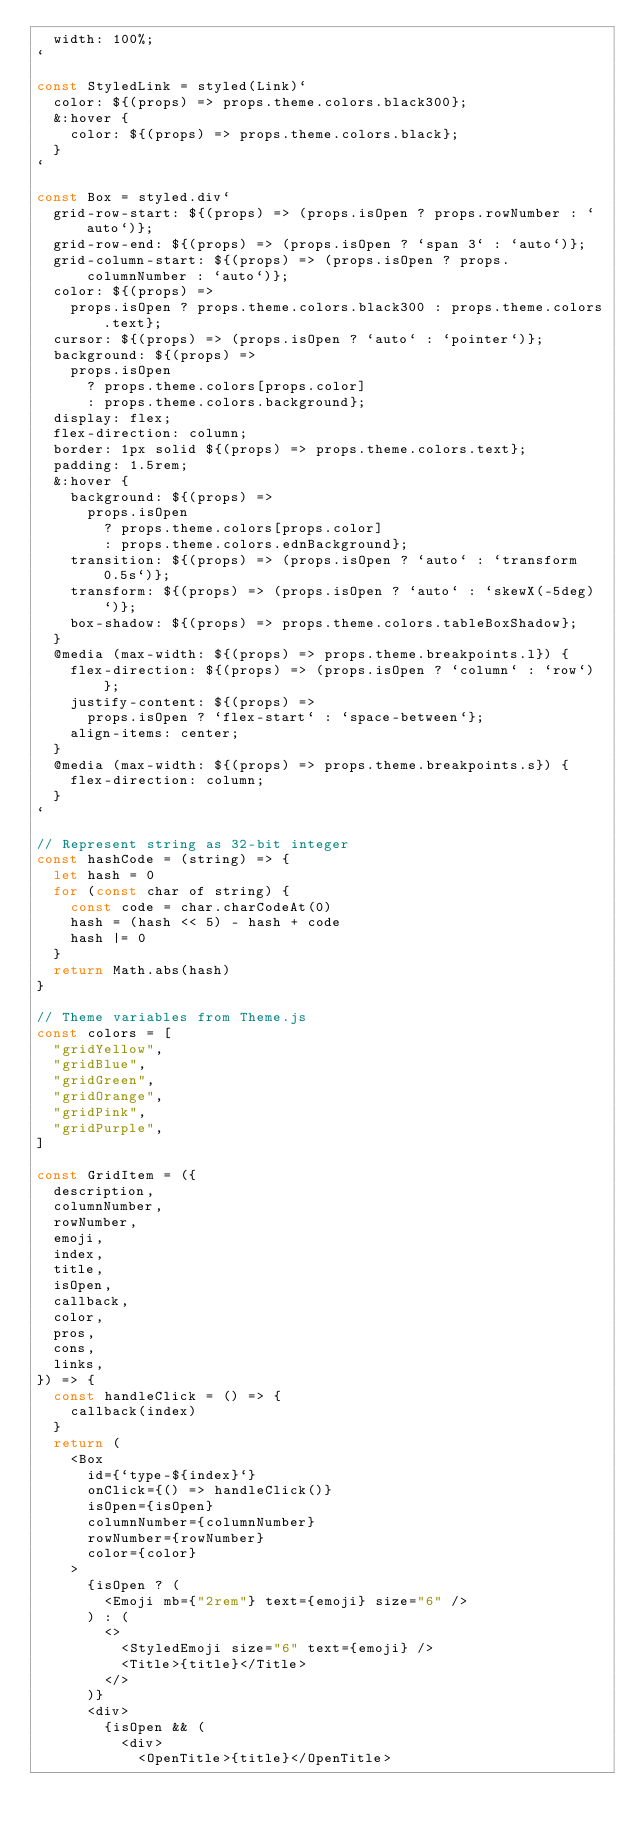<code> <loc_0><loc_0><loc_500><loc_500><_JavaScript_>  width: 100%;
`

const StyledLink = styled(Link)`
  color: ${(props) => props.theme.colors.black300};
  &:hover {
    color: ${(props) => props.theme.colors.black};
  }
`

const Box = styled.div`
  grid-row-start: ${(props) => (props.isOpen ? props.rowNumber : `auto`)};
  grid-row-end: ${(props) => (props.isOpen ? `span 3` : `auto`)};
  grid-column-start: ${(props) => (props.isOpen ? props.columnNumber : `auto`)};
  color: ${(props) =>
    props.isOpen ? props.theme.colors.black300 : props.theme.colors.text};
  cursor: ${(props) => (props.isOpen ? `auto` : `pointer`)};
  background: ${(props) =>
    props.isOpen
      ? props.theme.colors[props.color]
      : props.theme.colors.background};
  display: flex;
  flex-direction: column;
  border: 1px solid ${(props) => props.theme.colors.text};
  padding: 1.5rem;
  &:hover {
    background: ${(props) =>
      props.isOpen
        ? props.theme.colors[props.color]
        : props.theme.colors.ednBackground};
    transition: ${(props) => (props.isOpen ? `auto` : `transform 0.5s`)};
    transform: ${(props) => (props.isOpen ? `auto` : `skewX(-5deg)`)};
    box-shadow: ${(props) => props.theme.colors.tableBoxShadow};
  }
  @media (max-width: ${(props) => props.theme.breakpoints.l}) {
    flex-direction: ${(props) => (props.isOpen ? `column` : `row`)};
    justify-content: ${(props) =>
      props.isOpen ? `flex-start` : `space-between`};
    align-items: center;
  }
  @media (max-width: ${(props) => props.theme.breakpoints.s}) {
    flex-direction: column;
  }
`

// Represent string as 32-bit integer
const hashCode = (string) => {
  let hash = 0
  for (const char of string) {
    const code = char.charCodeAt(0)
    hash = (hash << 5) - hash + code
    hash |= 0
  }
  return Math.abs(hash)
}

// Theme variables from Theme.js
const colors = [
  "gridYellow",
  "gridBlue",
  "gridGreen",
  "gridOrange",
  "gridPink",
  "gridPurple",
]

const GridItem = ({
  description,
  columnNumber,
  rowNumber,
  emoji,
  index,
  title,
  isOpen,
  callback,
  color,
  pros,
  cons,
  links,
}) => {
  const handleClick = () => {
    callback(index)
  }
  return (
    <Box
      id={`type-${index}`}
      onClick={() => handleClick()}
      isOpen={isOpen}
      columnNumber={columnNumber}
      rowNumber={rowNumber}
      color={color}
    >
      {isOpen ? (
        <Emoji mb={"2rem"} text={emoji} size="6" />
      ) : (
        <>
          <StyledEmoji size="6" text={emoji} />
          <Title>{title}</Title>
        </>
      )}
      <div>
        {isOpen && (
          <div>
            <OpenTitle>{title}</OpenTitle></code> 